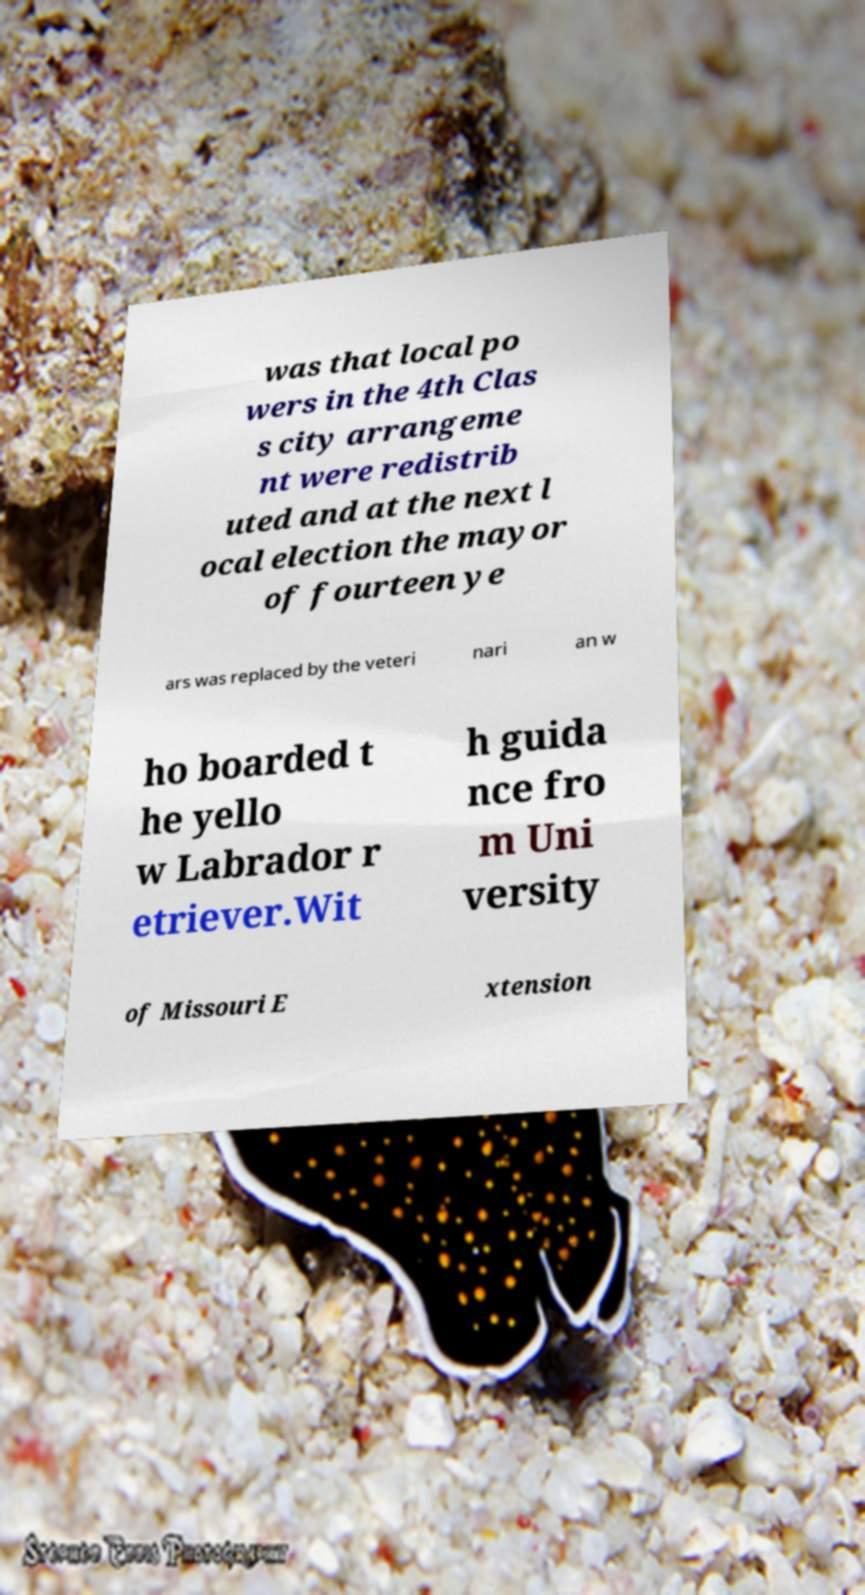For documentation purposes, I need the text within this image transcribed. Could you provide that? was that local po wers in the 4th Clas s city arrangeme nt were redistrib uted and at the next l ocal election the mayor of fourteen ye ars was replaced by the veteri nari an w ho boarded t he yello w Labrador r etriever.Wit h guida nce fro m Uni versity of Missouri E xtension 